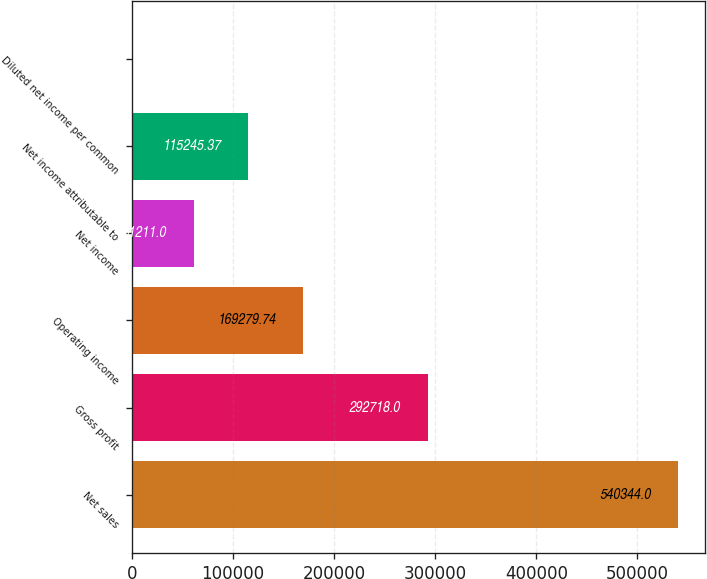Convert chart. <chart><loc_0><loc_0><loc_500><loc_500><bar_chart><fcel>Net sales<fcel>Gross profit<fcel>Operating income<fcel>Net income<fcel>Net income attributable to<fcel>Diluted net income per common<nl><fcel>540344<fcel>292718<fcel>169280<fcel>61211<fcel>115245<fcel>0.28<nl></chart> 